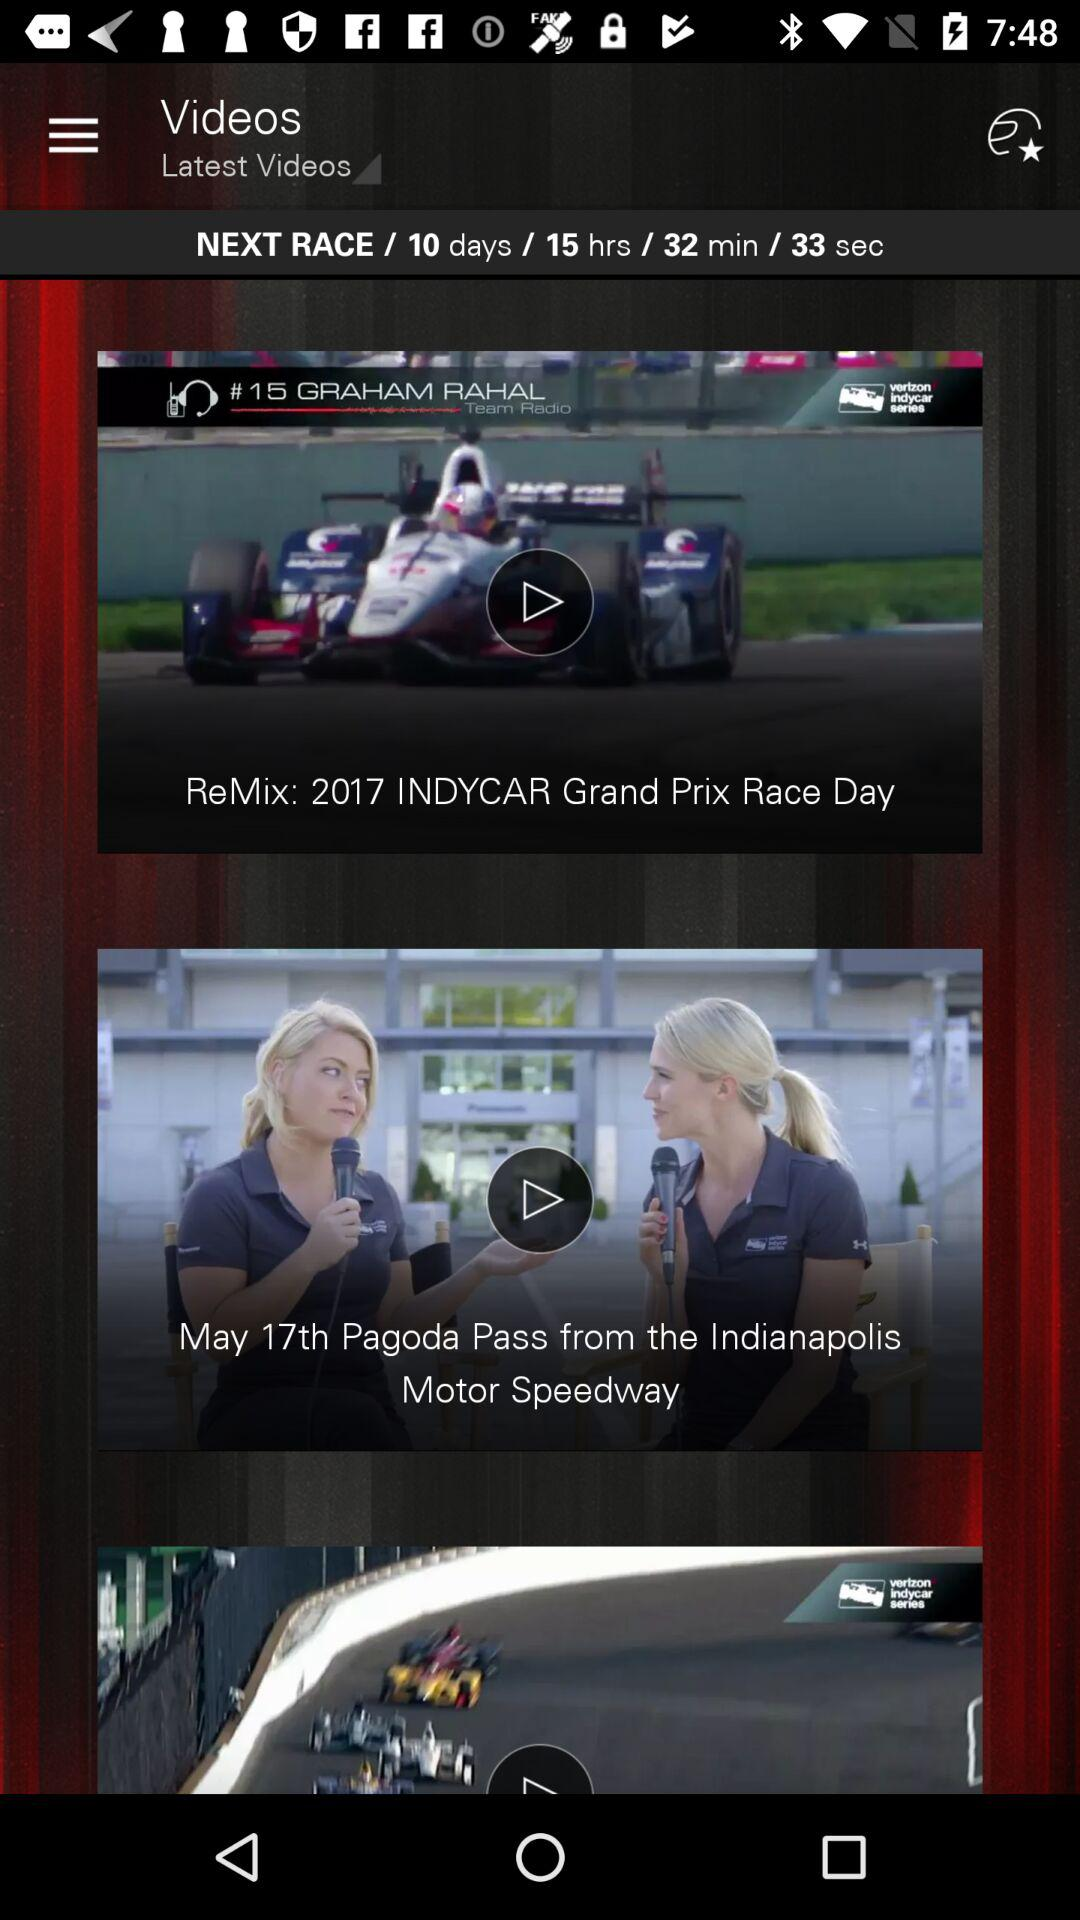What is the time left for the next race? The time left for the next race is 10 days 15 hours 32 minutes 33 seconds. 